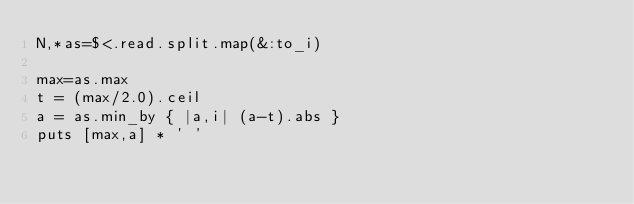Convert code to text. <code><loc_0><loc_0><loc_500><loc_500><_Ruby_>N,*as=$<.read.split.map(&:to_i)

max=as.max
t = (max/2.0).ceil
a = as.min_by { |a,i| (a-t).abs }
puts [max,a] * ' '
</code> 